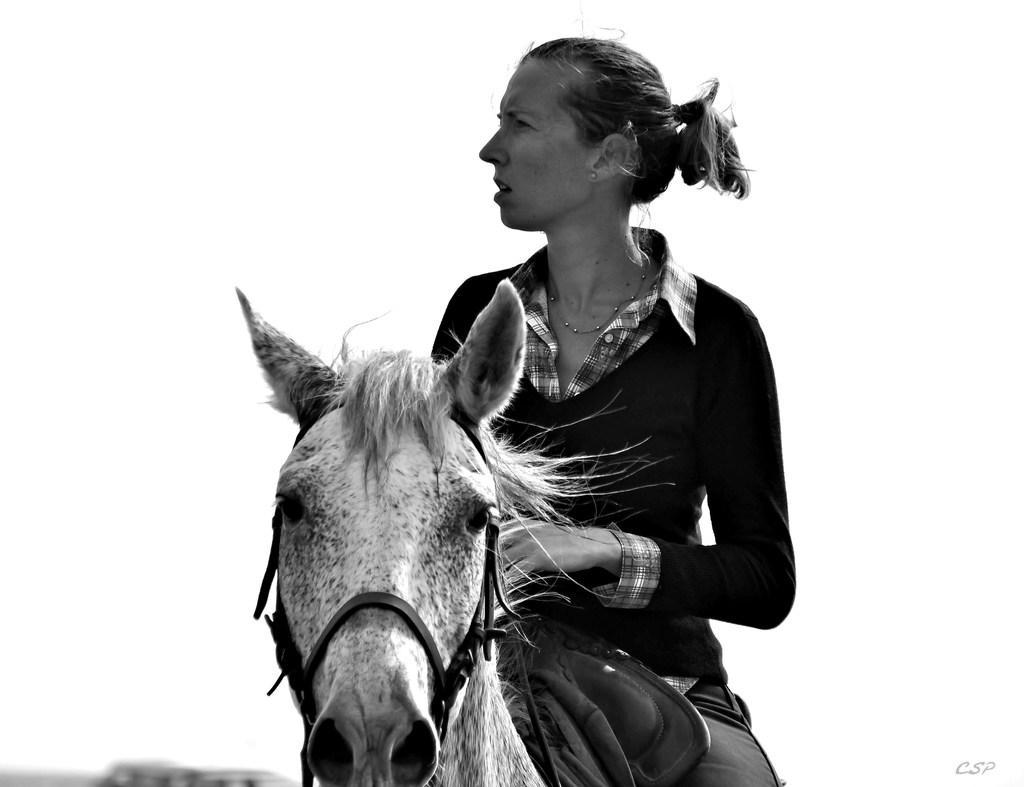In one or two sentences, can you explain what this image depicts? In this picture we can see woman sitting on horse and looking at something and in the background we can see sky. 